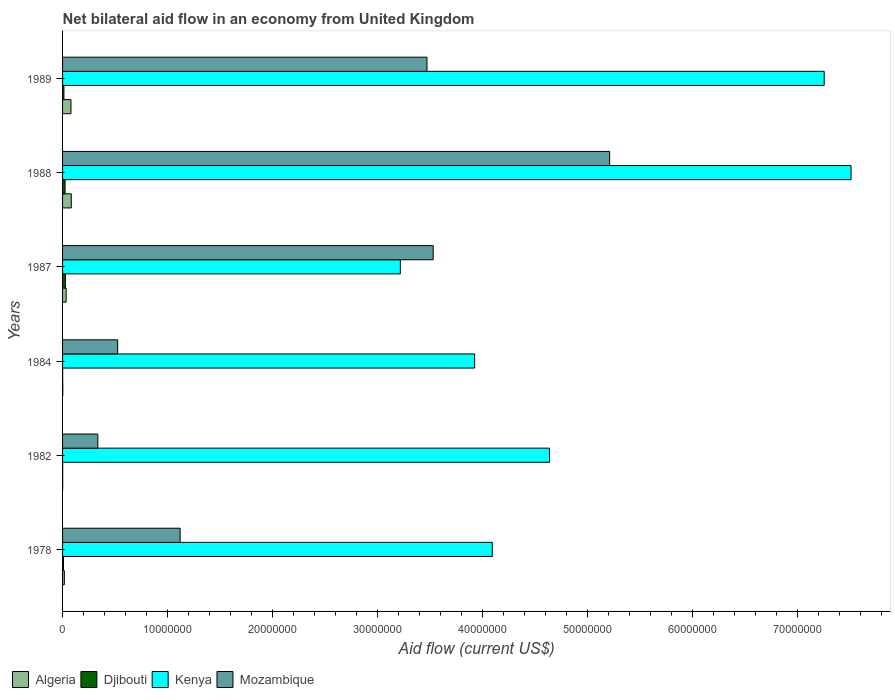How many different coloured bars are there?
Ensure brevity in your answer.  4. How many groups of bars are there?
Give a very brief answer. 6. Are the number of bars per tick equal to the number of legend labels?
Your response must be concise. Yes. How many bars are there on the 2nd tick from the bottom?
Provide a short and direct response. 4. What is the net bilateral aid flow in Kenya in 1988?
Your response must be concise. 7.51e+07. Across all years, what is the maximum net bilateral aid flow in Djibouti?
Ensure brevity in your answer.  2.70e+05. Across all years, what is the minimum net bilateral aid flow in Kenya?
Offer a very short reply. 3.22e+07. In which year was the net bilateral aid flow in Mozambique maximum?
Your answer should be compact. 1988. What is the total net bilateral aid flow in Djibouti in the graph?
Offer a terse response. 7.50e+05. What is the difference between the net bilateral aid flow in Mozambique in 1982 and that in 1988?
Offer a terse response. -4.88e+07. What is the difference between the net bilateral aid flow in Djibouti in 1978 and the net bilateral aid flow in Mozambique in 1984?
Provide a short and direct response. -5.16e+06. What is the average net bilateral aid flow in Djibouti per year?
Offer a very short reply. 1.25e+05. In the year 1984, what is the difference between the net bilateral aid flow in Mozambique and net bilateral aid flow in Kenya?
Provide a succinct answer. -3.40e+07. In how many years, is the net bilateral aid flow in Mozambique greater than 20000000 US$?
Make the answer very short. 3. What is the ratio of the net bilateral aid flow in Mozambique in 1984 to that in 1988?
Provide a short and direct response. 0.1. Is the net bilateral aid flow in Djibouti in 1984 less than that in 1988?
Your answer should be compact. Yes. Is the difference between the net bilateral aid flow in Mozambique in 1984 and 1989 greater than the difference between the net bilateral aid flow in Kenya in 1984 and 1989?
Your answer should be very brief. Yes. What is the difference between the highest and the second highest net bilateral aid flow in Mozambique?
Your response must be concise. 1.68e+07. Is the sum of the net bilateral aid flow in Kenya in 1987 and 1989 greater than the maximum net bilateral aid flow in Algeria across all years?
Your answer should be very brief. Yes. What does the 4th bar from the top in 1978 represents?
Give a very brief answer. Algeria. What does the 4th bar from the bottom in 1982 represents?
Your answer should be compact. Mozambique. Is it the case that in every year, the sum of the net bilateral aid flow in Kenya and net bilateral aid flow in Mozambique is greater than the net bilateral aid flow in Algeria?
Make the answer very short. Yes. How many bars are there?
Ensure brevity in your answer.  24. How many years are there in the graph?
Provide a succinct answer. 6. What is the difference between two consecutive major ticks on the X-axis?
Keep it short and to the point. 1.00e+07. Where does the legend appear in the graph?
Your answer should be very brief. Bottom left. How many legend labels are there?
Your response must be concise. 4. What is the title of the graph?
Your response must be concise. Net bilateral aid flow in an economy from United Kingdom. What is the Aid flow (current US$) in Algeria in 1978?
Your answer should be compact. 1.70e+05. What is the Aid flow (current US$) of Kenya in 1978?
Ensure brevity in your answer.  4.09e+07. What is the Aid flow (current US$) in Mozambique in 1978?
Your answer should be very brief. 1.12e+07. What is the Aid flow (current US$) in Kenya in 1982?
Provide a succinct answer. 4.64e+07. What is the Aid flow (current US$) of Mozambique in 1982?
Your answer should be very brief. 3.36e+06. What is the Aid flow (current US$) of Djibouti in 1984?
Your answer should be very brief. 10000. What is the Aid flow (current US$) of Kenya in 1984?
Offer a very short reply. 3.93e+07. What is the Aid flow (current US$) in Mozambique in 1984?
Your answer should be very brief. 5.25e+06. What is the Aid flow (current US$) in Djibouti in 1987?
Your answer should be very brief. 2.70e+05. What is the Aid flow (current US$) of Kenya in 1987?
Offer a very short reply. 3.22e+07. What is the Aid flow (current US$) in Mozambique in 1987?
Your response must be concise. 3.53e+07. What is the Aid flow (current US$) of Algeria in 1988?
Provide a short and direct response. 8.30e+05. What is the Aid flow (current US$) in Djibouti in 1988?
Your response must be concise. 2.40e+05. What is the Aid flow (current US$) of Kenya in 1988?
Provide a succinct answer. 7.51e+07. What is the Aid flow (current US$) of Mozambique in 1988?
Make the answer very short. 5.21e+07. What is the Aid flow (current US$) of Kenya in 1989?
Give a very brief answer. 7.26e+07. What is the Aid flow (current US$) in Mozambique in 1989?
Offer a very short reply. 3.47e+07. Across all years, what is the maximum Aid flow (current US$) of Algeria?
Provide a short and direct response. 8.30e+05. Across all years, what is the maximum Aid flow (current US$) of Djibouti?
Provide a short and direct response. 2.70e+05. Across all years, what is the maximum Aid flow (current US$) of Kenya?
Ensure brevity in your answer.  7.51e+07. Across all years, what is the maximum Aid flow (current US$) of Mozambique?
Offer a terse response. 5.21e+07. Across all years, what is the minimum Aid flow (current US$) of Djibouti?
Keep it short and to the point. 10000. Across all years, what is the minimum Aid flow (current US$) in Kenya?
Give a very brief answer. 3.22e+07. Across all years, what is the minimum Aid flow (current US$) of Mozambique?
Ensure brevity in your answer.  3.36e+06. What is the total Aid flow (current US$) of Algeria in the graph?
Keep it short and to the point. 2.17e+06. What is the total Aid flow (current US$) of Djibouti in the graph?
Offer a terse response. 7.50e+05. What is the total Aid flow (current US$) of Kenya in the graph?
Your answer should be very brief. 3.06e+08. What is the total Aid flow (current US$) of Mozambique in the graph?
Provide a succinct answer. 1.42e+08. What is the difference between the Aid flow (current US$) in Algeria in 1978 and that in 1982?
Make the answer very short. 1.60e+05. What is the difference between the Aid flow (current US$) of Kenya in 1978 and that in 1982?
Offer a terse response. -5.45e+06. What is the difference between the Aid flow (current US$) of Mozambique in 1978 and that in 1982?
Provide a short and direct response. 7.84e+06. What is the difference between the Aid flow (current US$) in Kenya in 1978 and that in 1984?
Provide a short and direct response. 1.68e+06. What is the difference between the Aid flow (current US$) in Mozambique in 1978 and that in 1984?
Your answer should be very brief. 5.95e+06. What is the difference between the Aid flow (current US$) of Kenya in 1978 and that in 1987?
Your response must be concise. 8.76e+06. What is the difference between the Aid flow (current US$) in Mozambique in 1978 and that in 1987?
Keep it short and to the point. -2.41e+07. What is the difference between the Aid flow (current US$) in Algeria in 1978 and that in 1988?
Ensure brevity in your answer.  -6.60e+05. What is the difference between the Aid flow (current US$) of Djibouti in 1978 and that in 1988?
Ensure brevity in your answer.  -1.50e+05. What is the difference between the Aid flow (current US$) in Kenya in 1978 and that in 1988?
Your answer should be compact. -3.42e+07. What is the difference between the Aid flow (current US$) of Mozambique in 1978 and that in 1988?
Make the answer very short. -4.09e+07. What is the difference between the Aid flow (current US$) in Algeria in 1978 and that in 1989?
Your response must be concise. -6.30e+05. What is the difference between the Aid flow (current US$) in Djibouti in 1978 and that in 1989?
Offer a very short reply. -4.00e+04. What is the difference between the Aid flow (current US$) of Kenya in 1978 and that in 1989?
Keep it short and to the point. -3.16e+07. What is the difference between the Aid flow (current US$) of Mozambique in 1978 and that in 1989?
Offer a very short reply. -2.35e+07. What is the difference between the Aid flow (current US$) of Djibouti in 1982 and that in 1984?
Make the answer very short. 0. What is the difference between the Aid flow (current US$) of Kenya in 1982 and that in 1984?
Your response must be concise. 7.13e+06. What is the difference between the Aid flow (current US$) of Mozambique in 1982 and that in 1984?
Give a very brief answer. -1.89e+06. What is the difference between the Aid flow (current US$) in Algeria in 1982 and that in 1987?
Keep it short and to the point. -3.30e+05. What is the difference between the Aid flow (current US$) of Kenya in 1982 and that in 1987?
Your response must be concise. 1.42e+07. What is the difference between the Aid flow (current US$) of Mozambique in 1982 and that in 1987?
Your answer should be very brief. -3.20e+07. What is the difference between the Aid flow (current US$) in Algeria in 1982 and that in 1988?
Your answer should be very brief. -8.20e+05. What is the difference between the Aid flow (current US$) in Kenya in 1982 and that in 1988?
Offer a terse response. -2.87e+07. What is the difference between the Aid flow (current US$) of Mozambique in 1982 and that in 1988?
Provide a succinct answer. -4.88e+07. What is the difference between the Aid flow (current US$) of Algeria in 1982 and that in 1989?
Your response must be concise. -7.90e+05. What is the difference between the Aid flow (current US$) of Djibouti in 1982 and that in 1989?
Your response must be concise. -1.20e+05. What is the difference between the Aid flow (current US$) in Kenya in 1982 and that in 1989?
Ensure brevity in your answer.  -2.62e+07. What is the difference between the Aid flow (current US$) of Mozambique in 1982 and that in 1989?
Your answer should be compact. -3.14e+07. What is the difference between the Aid flow (current US$) in Algeria in 1984 and that in 1987?
Your answer should be compact. -3.20e+05. What is the difference between the Aid flow (current US$) in Kenya in 1984 and that in 1987?
Provide a succinct answer. 7.08e+06. What is the difference between the Aid flow (current US$) in Mozambique in 1984 and that in 1987?
Your answer should be compact. -3.01e+07. What is the difference between the Aid flow (current US$) in Algeria in 1984 and that in 1988?
Your response must be concise. -8.10e+05. What is the difference between the Aid flow (current US$) in Kenya in 1984 and that in 1988?
Offer a terse response. -3.59e+07. What is the difference between the Aid flow (current US$) of Mozambique in 1984 and that in 1988?
Your answer should be compact. -4.69e+07. What is the difference between the Aid flow (current US$) of Algeria in 1984 and that in 1989?
Offer a very short reply. -7.80e+05. What is the difference between the Aid flow (current US$) in Kenya in 1984 and that in 1989?
Offer a terse response. -3.33e+07. What is the difference between the Aid flow (current US$) in Mozambique in 1984 and that in 1989?
Keep it short and to the point. -2.95e+07. What is the difference between the Aid flow (current US$) in Algeria in 1987 and that in 1988?
Your answer should be compact. -4.90e+05. What is the difference between the Aid flow (current US$) in Djibouti in 1987 and that in 1988?
Provide a short and direct response. 3.00e+04. What is the difference between the Aid flow (current US$) of Kenya in 1987 and that in 1988?
Offer a very short reply. -4.29e+07. What is the difference between the Aid flow (current US$) in Mozambique in 1987 and that in 1988?
Your response must be concise. -1.68e+07. What is the difference between the Aid flow (current US$) of Algeria in 1987 and that in 1989?
Give a very brief answer. -4.60e+05. What is the difference between the Aid flow (current US$) of Djibouti in 1987 and that in 1989?
Ensure brevity in your answer.  1.40e+05. What is the difference between the Aid flow (current US$) in Kenya in 1987 and that in 1989?
Provide a succinct answer. -4.04e+07. What is the difference between the Aid flow (current US$) of Mozambique in 1987 and that in 1989?
Keep it short and to the point. 5.90e+05. What is the difference between the Aid flow (current US$) of Djibouti in 1988 and that in 1989?
Ensure brevity in your answer.  1.10e+05. What is the difference between the Aid flow (current US$) of Kenya in 1988 and that in 1989?
Offer a very short reply. 2.56e+06. What is the difference between the Aid flow (current US$) of Mozambique in 1988 and that in 1989?
Keep it short and to the point. 1.74e+07. What is the difference between the Aid flow (current US$) in Algeria in 1978 and the Aid flow (current US$) in Djibouti in 1982?
Ensure brevity in your answer.  1.60e+05. What is the difference between the Aid flow (current US$) of Algeria in 1978 and the Aid flow (current US$) of Kenya in 1982?
Your answer should be compact. -4.62e+07. What is the difference between the Aid flow (current US$) in Algeria in 1978 and the Aid flow (current US$) in Mozambique in 1982?
Keep it short and to the point. -3.19e+06. What is the difference between the Aid flow (current US$) in Djibouti in 1978 and the Aid flow (current US$) in Kenya in 1982?
Provide a succinct answer. -4.63e+07. What is the difference between the Aid flow (current US$) of Djibouti in 1978 and the Aid flow (current US$) of Mozambique in 1982?
Provide a succinct answer. -3.27e+06. What is the difference between the Aid flow (current US$) in Kenya in 1978 and the Aid flow (current US$) in Mozambique in 1982?
Ensure brevity in your answer.  3.76e+07. What is the difference between the Aid flow (current US$) in Algeria in 1978 and the Aid flow (current US$) in Djibouti in 1984?
Keep it short and to the point. 1.60e+05. What is the difference between the Aid flow (current US$) of Algeria in 1978 and the Aid flow (current US$) of Kenya in 1984?
Your answer should be compact. -3.91e+07. What is the difference between the Aid flow (current US$) in Algeria in 1978 and the Aid flow (current US$) in Mozambique in 1984?
Your response must be concise. -5.08e+06. What is the difference between the Aid flow (current US$) in Djibouti in 1978 and the Aid flow (current US$) in Kenya in 1984?
Make the answer very short. -3.92e+07. What is the difference between the Aid flow (current US$) in Djibouti in 1978 and the Aid flow (current US$) in Mozambique in 1984?
Your response must be concise. -5.16e+06. What is the difference between the Aid flow (current US$) of Kenya in 1978 and the Aid flow (current US$) of Mozambique in 1984?
Your response must be concise. 3.57e+07. What is the difference between the Aid flow (current US$) of Algeria in 1978 and the Aid flow (current US$) of Kenya in 1987?
Provide a short and direct response. -3.20e+07. What is the difference between the Aid flow (current US$) of Algeria in 1978 and the Aid flow (current US$) of Mozambique in 1987?
Your answer should be compact. -3.51e+07. What is the difference between the Aid flow (current US$) in Djibouti in 1978 and the Aid flow (current US$) in Kenya in 1987?
Your answer should be very brief. -3.21e+07. What is the difference between the Aid flow (current US$) in Djibouti in 1978 and the Aid flow (current US$) in Mozambique in 1987?
Your answer should be very brief. -3.52e+07. What is the difference between the Aid flow (current US$) in Kenya in 1978 and the Aid flow (current US$) in Mozambique in 1987?
Ensure brevity in your answer.  5.63e+06. What is the difference between the Aid flow (current US$) of Algeria in 1978 and the Aid flow (current US$) of Djibouti in 1988?
Make the answer very short. -7.00e+04. What is the difference between the Aid flow (current US$) in Algeria in 1978 and the Aid flow (current US$) in Kenya in 1988?
Provide a succinct answer. -7.50e+07. What is the difference between the Aid flow (current US$) in Algeria in 1978 and the Aid flow (current US$) in Mozambique in 1988?
Your response must be concise. -5.20e+07. What is the difference between the Aid flow (current US$) of Djibouti in 1978 and the Aid flow (current US$) of Kenya in 1988?
Make the answer very short. -7.50e+07. What is the difference between the Aid flow (current US$) in Djibouti in 1978 and the Aid flow (current US$) in Mozambique in 1988?
Your answer should be very brief. -5.20e+07. What is the difference between the Aid flow (current US$) of Kenya in 1978 and the Aid flow (current US$) of Mozambique in 1988?
Your response must be concise. -1.12e+07. What is the difference between the Aid flow (current US$) of Algeria in 1978 and the Aid flow (current US$) of Djibouti in 1989?
Your answer should be compact. 4.00e+04. What is the difference between the Aid flow (current US$) in Algeria in 1978 and the Aid flow (current US$) in Kenya in 1989?
Your answer should be compact. -7.24e+07. What is the difference between the Aid flow (current US$) in Algeria in 1978 and the Aid flow (current US$) in Mozambique in 1989?
Give a very brief answer. -3.46e+07. What is the difference between the Aid flow (current US$) in Djibouti in 1978 and the Aid flow (current US$) in Kenya in 1989?
Give a very brief answer. -7.25e+07. What is the difference between the Aid flow (current US$) in Djibouti in 1978 and the Aid flow (current US$) in Mozambique in 1989?
Give a very brief answer. -3.46e+07. What is the difference between the Aid flow (current US$) of Kenya in 1978 and the Aid flow (current US$) of Mozambique in 1989?
Provide a short and direct response. 6.22e+06. What is the difference between the Aid flow (current US$) in Algeria in 1982 and the Aid flow (current US$) in Djibouti in 1984?
Keep it short and to the point. 0. What is the difference between the Aid flow (current US$) of Algeria in 1982 and the Aid flow (current US$) of Kenya in 1984?
Give a very brief answer. -3.92e+07. What is the difference between the Aid flow (current US$) in Algeria in 1982 and the Aid flow (current US$) in Mozambique in 1984?
Ensure brevity in your answer.  -5.24e+06. What is the difference between the Aid flow (current US$) in Djibouti in 1982 and the Aid flow (current US$) in Kenya in 1984?
Your answer should be compact. -3.92e+07. What is the difference between the Aid flow (current US$) in Djibouti in 1982 and the Aid flow (current US$) in Mozambique in 1984?
Give a very brief answer. -5.24e+06. What is the difference between the Aid flow (current US$) of Kenya in 1982 and the Aid flow (current US$) of Mozambique in 1984?
Make the answer very short. 4.11e+07. What is the difference between the Aid flow (current US$) of Algeria in 1982 and the Aid flow (current US$) of Djibouti in 1987?
Your response must be concise. -2.60e+05. What is the difference between the Aid flow (current US$) of Algeria in 1982 and the Aid flow (current US$) of Kenya in 1987?
Ensure brevity in your answer.  -3.22e+07. What is the difference between the Aid flow (current US$) of Algeria in 1982 and the Aid flow (current US$) of Mozambique in 1987?
Keep it short and to the point. -3.53e+07. What is the difference between the Aid flow (current US$) of Djibouti in 1982 and the Aid flow (current US$) of Kenya in 1987?
Your answer should be compact. -3.22e+07. What is the difference between the Aid flow (current US$) of Djibouti in 1982 and the Aid flow (current US$) of Mozambique in 1987?
Provide a succinct answer. -3.53e+07. What is the difference between the Aid flow (current US$) of Kenya in 1982 and the Aid flow (current US$) of Mozambique in 1987?
Offer a terse response. 1.11e+07. What is the difference between the Aid flow (current US$) of Algeria in 1982 and the Aid flow (current US$) of Kenya in 1988?
Your answer should be compact. -7.51e+07. What is the difference between the Aid flow (current US$) of Algeria in 1982 and the Aid flow (current US$) of Mozambique in 1988?
Make the answer very short. -5.21e+07. What is the difference between the Aid flow (current US$) of Djibouti in 1982 and the Aid flow (current US$) of Kenya in 1988?
Your answer should be very brief. -7.51e+07. What is the difference between the Aid flow (current US$) in Djibouti in 1982 and the Aid flow (current US$) in Mozambique in 1988?
Your answer should be very brief. -5.21e+07. What is the difference between the Aid flow (current US$) in Kenya in 1982 and the Aid flow (current US$) in Mozambique in 1988?
Offer a very short reply. -5.73e+06. What is the difference between the Aid flow (current US$) of Algeria in 1982 and the Aid flow (current US$) of Djibouti in 1989?
Offer a very short reply. -1.20e+05. What is the difference between the Aid flow (current US$) in Algeria in 1982 and the Aid flow (current US$) in Kenya in 1989?
Provide a short and direct response. -7.26e+07. What is the difference between the Aid flow (current US$) in Algeria in 1982 and the Aid flow (current US$) in Mozambique in 1989?
Your answer should be very brief. -3.47e+07. What is the difference between the Aid flow (current US$) of Djibouti in 1982 and the Aid flow (current US$) of Kenya in 1989?
Make the answer very short. -7.26e+07. What is the difference between the Aid flow (current US$) of Djibouti in 1982 and the Aid flow (current US$) of Mozambique in 1989?
Offer a very short reply. -3.47e+07. What is the difference between the Aid flow (current US$) in Kenya in 1982 and the Aid flow (current US$) in Mozambique in 1989?
Give a very brief answer. 1.17e+07. What is the difference between the Aid flow (current US$) of Algeria in 1984 and the Aid flow (current US$) of Djibouti in 1987?
Your answer should be very brief. -2.50e+05. What is the difference between the Aid flow (current US$) of Algeria in 1984 and the Aid flow (current US$) of Kenya in 1987?
Provide a short and direct response. -3.22e+07. What is the difference between the Aid flow (current US$) of Algeria in 1984 and the Aid flow (current US$) of Mozambique in 1987?
Ensure brevity in your answer.  -3.53e+07. What is the difference between the Aid flow (current US$) in Djibouti in 1984 and the Aid flow (current US$) in Kenya in 1987?
Provide a succinct answer. -3.22e+07. What is the difference between the Aid flow (current US$) in Djibouti in 1984 and the Aid flow (current US$) in Mozambique in 1987?
Provide a succinct answer. -3.53e+07. What is the difference between the Aid flow (current US$) in Kenya in 1984 and the Aid flow (current US$) in Mozambique in 1987?
Your answer should be very brief. 3.95e+06. What is the difference between the Aid flow (current US$) in Algeria in 1984 and the Aid flow (current US$) in Djibouti in 1988?
Your response must be concise. -2.20e+05. What is the difference between the Aid flow (current US$) of Algeria in 1984 and the Aid flow (current US$) of Kenya in 1988?
Provide a succinct answer. -7.51e+07. What is the difference between the Aid flow (current US$) of Algeria in 1984 and the Aid flow (current US$) of Mozambique in 1988?
Offer a terse response. -5.21e+07. What is the difference between the Aid flow (current US$) in Djibouti in 1984 and the Aid flow (current US$) in Kenya in 1988?
Your answer should be very brief. -7.51e+07. What is the difference between the Aid flow (current US$) of Djibouti in 1984 and the Aid flow (current US$) of Mozambique in 1988?
Keep it short and to the point. -5.21e+07. What is the difference between the Aid flow (current US$) of Kenya in 1984 and the Aid flow (current US$) of Mozambique in 1988?
Your response must be concise. -1.29e+07. What is the difference between the Aid flow (current US$) in Algeria in 1984 and the Aid flow (current US$) in Kenya in 1989?
Provide a short and direct response. -7.25e+07. What is the difference between the Aid flow (current US$) of Algeria in 1984 and the Aid flow (current US$) of Mozambique in 1989?
Keep it short and to the point. -3.47e+07. What is the difference between the Aid flow (current US$) of Djibouti in 1984 and the Aid flow (current US$) of Kenya in 1989?
Offer a terse response. -7.26e+07. What is the difference between the Aid flow (current US$) of Djibouti in 1984 and the Aid flow (current US$) of Mozambique in 1989?
Your answer should be very brief. -3.47e+07. What is the difference between the Aid flow (current US$) of Kenya in 1984 and the Aid flow (current US$) of Mozambique in 1989?
Your response must be concise. 4.54e+06. What is the difference between the Aid flow (current US$) in Algeria in 1987 and the Aid flow (current US$) in Kenya in 1988?
Keep it short and to the point. -7.48e+07. What is the difference between the Aid flow (current US$) in Algeria in 1987 and the Aid flow (current US$) in Mozambique in 1988?
Provide a succinct answer. -5.18e+07. What is the difference between the Aid flow (current US$) of Djibouti in 1987 and the Aid flow (current US$) of Kenya in 1988?
Ensure brevity in your answer.  -7.48e+07. What is the difference between the Aid flow (current US$) in Djibouti in 1987 and the Aid flow (current US$) in Mozambique in 1988?
Your answer should be very brief. -5.18e+07. What is the difference between the Aid flow (current US$) of Kenya in 1987 and the Aid flow (current US$) of Mozambique in 1988?
Keep it short and to the point. -1.99e+07. What is the difference between the Aid flow (current US$) in Algeria in 1987 and the Aid flow (current US$) in Djibouti in 1989?
Provide a short and direct response. 2.10e+05. What is the difference between the Aid flow (current US$) of Algeria in 1987 and the Aid flow (current US$) of Kenya in 1989?
Your answer should be compact. -7.22e+07. What is the difference between the Aid flow (current US$) in Algeria in 1987 and the Aid flow (current US$) in Mozambique in 1989?
Provide a short and direct response. -3.44e+07. What is the difference between the Aid flow (current US$) of Djibouti in 1987 and the Aid flow (current US$) of Kenya in 1989?
Offer a terse response. -7.23e+07. What is the difference between the Aid flow (current US$) in Djibouti in 1987 and the Aid flow (current US$) in Mozambique in 1989?
Keep it short and to the point. -3.44e+07. What is the difference between the Aid flow (current US$) in Kenya in 1987 and the Aid flow (current US$) in Mozambique in 1989?
Provide a short and direct response. -2.54e+06. What is the difference between the Aid flow (current US$) in Algeria in 1988 and the Aid flow (current US$) in Kenya in 1989?
Keep it short and to the point. -7.17e+07. What is the difference between the Aid flow (current US$) in Algeria in 1988 and the Aid flow (current US$) in Mozambique in 1989?
Keep it short and to the point. -3.39e+07. What is the difference between the Aid flow (current US$) in Djibouti in 1988 and the Aid flow (current US$) in Kenya in 1989?
Offer a terse response. -7.23e+07. What is the difference between the Aid flow (current US$) in Djibouti in 1988 and the Aid flow (current US$) in Mozambique in 1989?
Offer a very short reply. -3.45e+07. What is the difference between the Aid flow (current US$) of Kenya in 1988 and the Aid flow (current US$) of Mozambique in 1989?
Give a very brief answer. 4.04e+07. What is the average Aid flow (current US$) of Algeria per year?
Your answer should be compact. 3.62e+05. What is the average Aid flow (current US$) in Djibouti per year?
Provide a succinct answer. 1.25e+05. What is the average Aid flow (current US$) in Kenya per year?
Ensure brevity in your answer.  5.11e+07. What is the average Aid flow (current US$) of Mozambique per year?
Your answer should be very brief. 2.37e+07. In the year 1978, what is the difference between the Aid flow (current US$) in Algeria and Aid flow (current US$) in Kenya?
Your response must be concise. -4.08e+07. In the year 1978, what is the difference between the Aid flow (current US$) of Algeria and Aid flow (current US$) of Mozambique?
Your answer should be very brief. -1.10e+07. In the year 1978, what is the difference between the Aid flow (current US$) of Djibouti and Aid flow (current US$) of Kenya?
Your response must be concise. -4.08e+07. In the year 1978, what is the difference between the Aid flow (current US$) in Djibouti and Aid flow (current US$) in Mozambique?
Offer a terse response. -1.11e+07. In the year 1978, what is the difference between the Aid flow (current US$) in Kenya and Aid flow (current US$) in Mozambique?
Offer a very short reply. 2.97e+07. In the year 1982, what is the difference between the Aid flow (current US$) in Algeria and Aid flow (current US$) in Djibouti?
Your answer should be very brief. 0. In the year 1982, what is the difference between the Aid flow (current US$) in Algeria and Aid flow (current US$) in Kenya?
Offer a terse response. -4.64e+07. In the year 1982, what is the difference between the Aid flow (current US$) of Algeria and Aid flow (current US$) of Mozambique?
Keep it short and to the point. -3.35e+06. In the year 1982, what is the difference between the Aid flow (current US$) in Djibouti and Aid flow (current US$) in Kenya?
Make the answer very short. -4.64e+07. In the year 1982, what is the difference between the Aid flow (current US$) in Djibouti and Aid flow (current US$) in Mozambique?
Provide a short and direct response. -3.35e+06. In the year 1982, what is the difference between the Aid flow (current US$) in Kenya and Aid flow (current US$) in Mozambique?
Offer a terse response. 4.30e+07. In the year 1984, what is the difference between the Aid flow (current US$) in Algeria and Aid flow (current US$) in Djibouti?
Keep it short and to the point. 10000. In the year 1984, what is the difference between the Aid flow (current US$) of Algeria and Aid flow (current US$) of Kenya?
Keep it short and to the point. -3.92e+07. In the year 1984, what is the difference between the Aid flow (current US$) of Algeria and Aid flow (current US$) of Mozambique?
Provide a short and direct response. -5.23e+06. In the year 1984, what is the difference between the Aid flow (current US$) of Djibouti and Aid flow (current US$) of Kenya?
Your answer should be very brief. -3.92e+07. In the year 1984, what is the difference between the Aid flow (current US$) of Djibouti and Aid flow (current US$) of Mozambique?
Your response must be concise. -5.24e+06. In the year 1984, what is the difference between the Aid flow (current US$) in Kenya and Aid flow (current US$) in Mozambique?
Offer a terse response. 3.40e+07. In the year 1987, what is the difference between the Aid flow (current US$) in Algeria and Aid flow (current US$) in Kenya?
Provide a succinct answer. -3.18e+07. In the year 1987, what is the difference between the Aid flow (current US$) in Algeria and Aid flow (current US$) in Mozambique?
Offer a terse response. -3.50e+07. In the year 1987, what is the difference between the Aid flow (current US$) of Djibouti and Aid flow (current US$) of Kenya?
Ensure brevity in your answer.  -3.19e+07. In the year 1987, what is the difference between the Aid flow (current US$) in Djibouti and Aid flow (current US$) in Mozambique?
Keep it short and to the point. -3.50e+07. In the year 1987, what is the difference between the Aid flow (current US$) in Kenya and Aid flow (current US$) in Mozambique?
Keep it short and to the point. -3.13e+06. In the year 1988, what is the difference between the Aid flow (current US$) of Algeria and Aid flow (current US$) of Djibouti?
Your answer should be very brief. 5.90e+05. In the year 1988, what is the difference between the Aid flow (current US$) in Algeria and Aid flow (current US$) in Kenya?
Ensure brevity in your answer.  -7.43e+07. In the year 1988, what is the difference between the Aid flow (current US$) of Algeria and Aid flow (current US$) of Mozambique?
Your answer should be very brief. -5.13e+07. In the year 1988, what is the difference between the Aid flow (current US$) of Djibouti and Aid flow (current US$) of Kenya?
Keep it short and to the point. -7.49e+07. In the year 1988, what is the difference between the Aid flow (current US$) of Djibouti and Aid flow (current US$) of Mozambique?
Ensure brevity in your answer.  -5.19e+07. In the year 1988, what is the difference between the Aid flow (current US$) of Kenya and Aid flow (current US$) of Mozambique?
Give a very brief answer. 2.30e+07. In the year 1989, what is the difference between the Aid flow (current US$) in Algeria and Aid flow (current US$) in Djibouti?
Ensure brevity in your answer.  6.70e+05. In the year 1989, what is the difference between the Aid flow (current US$) in Algeria and Aid flow (current US$) in Kenya?
Keep it short and to the point. -7.18e+07. In the year 1989, what is the difference between the Aid flow (current US$) in Algeria and Aid flow (current US$) in Mozambique?
Make the answer very short. -3.39e+07. In the year 1989, what is the difference between the Aid flow (current US$) in Djibouti and Aid flow (current US$) in Kenya?
Offer a terse response. -7.24e+07. In the year 1989, what is the difference between the Aid flow (current US$) in Djibouti and Aid flow (current US$) in Mozambique?
Your answer should be very brief. -3.46e+07. In the year 1989, what is the difference between the Aid flow (current US$) in Kenya and Aid flow (current US$) in Mozambique?
Provide a short and direct response. 3.78e+07. What is the ratio of the Aid flow (current US$) in Algeria in 1978 to that in 1982?
Your answer should be very brief. 17. What is the ratio of the Aid flow (current US$) in Kenya in 1978 to that in 1982?
Keep it short and to the point. 0.88. What is the ratio of the Aid flow (current US$) of Djibouti in 1978 to that in 1984?
Offer a very short reply. 9. What is the ratio of the Aid flow (current US$) in Kenya in 1978 to that in 1984?
Ensure brevity in your answer.  1.04. What is the ratio of the Aid flow (current US$) of Mozambique in 1978 to that in 1984?
Offer a terse response. 2.13. What is the ratio of the Aid flow (current US$) of Algeria in 1978 to that in 1987?
Offer a terse response. 0.5. What is the ratio of the Aid flow (current US$) of Kenya in 1978 to that in 1987?
Make the answer very short. 1.27. What is the ratio of the Aid flow (current US$) in Mozambique in 1978 to that in 1987?
Make the answer very short. 0.32. What is the ratio of the Aid flow (current US$) in Algeria in 1978 to that in 1988?
Provide a short and direct response. 0.2. What is the ratio of the Aid flow (current US$) of Djibouti in 1978 to that in 1988?
Offer a terse response. 0.38. What is the ratio of the Aid flow (current US$) of Kenya in 1978 to that in 1988?
Offer a very short reply. 0.55. What is the ratio of the Aid flow (current US$) of Mozambique in 1978 to that in 1988?
Provide a short and direct response. 0.21. What is the ratio of the Aid flow (current US$) of Algeria in 1978 to that in 1989?
Give a very brief answer. 0.21. What is the ratio of the Aid flow (current US$) of Djibouti in 1978 to that in 1989?
Give a very brief answer. 0.69. What is the ratio of the Aid flow (current US$) of Kenya in 1978 to that in 1989?
Your response must be concise. 0.56. What is the ratio of the Aid flow (current US$) in Mozambique in 1978 to that in 1989?
Your answer should be compact. 0.32. What is the ratio of the Aid flow (current US$) in Kenya in 1982 to that in 1984?
Provide a succinct answer. 1.18. What is the ratio of the Aid flow (current US$) in Mozambique in 1982 to that in 1984?
Provide a succinct answer. 0.64. What is the ratio of the Aid flow (current US$) in Algeria in 1982 to that in 1987?
Provide a succinct answer. 0.03. What is the ratio of the Aid flow (current US$) in Djibouti in 1982 to that in 1987?
Ensure brevity in your answer.  0.04. What is the ratio of the Aid flow (current US$) in Kenya in 1982 to that in 1987?
Offer a terse response. 1.44. What is the ratio of the Aid flow (current US$) in Mozambique in 1982 to that in 1987?
Your answer should be compact. 0.1. What is the ratio of the Aid flow (current US$) in Algeria in 1982 to that in 1988?
Your answer should be compact. 0.01. What is the ratio of the Aid flow (current US$) of Djibouti in 1982 to that in 1988?
Offer a very short reply. 0.04. What is the ratio of the Aid flow (current US$) of Kenya in 1982 to that in 1988?
Your answer should be compact. 0.62. What is the ratio of the Aid flow (current US$) in Mozambique in 1982 to that in 1988?
Your response must be concise. 0.06. What is the ratio of the Aid flow (current US$) of Algeria in 1982 to that in 1989?
Offer a very short reply. 0.01. What is the ratio of the Aid flow (current US$) of Djibouti in 1982 to that in 1989?
Ensure brevity in your answer.  0.08. What is the ratio of the Aid flow (current US$) in Kenya in 1982 to that in 1989?
Give a very brief answer. 0.64. What is the ratio of the Aid flow (current US$) of Mozambique in 1982 to that in 1989?
Your answer should be compact. 0.1. What is the ratio of the Aid flow (current US$) of Algeria in 1984 to that in 1987?
Offer a terse response. 0.06. What is the ratio of the Aid flow (current US$) of Djibouti in 1984 to that in 1987?
Give a very brief answer. 0.04. What is the ratio of the Aid flow (current US$) of Kenya in 1984 to that in 1987?
Provide a succinct answer. 1.22. What is the ratio of the Aid flow (current US$) in Mozambique in 1984 to that in 1987?
Offer a very short reply. 0.15. What is the ratio of the Aid flow (current US$) of Algeria in 1984 to that in 1988?
Ensure brevity in your answer.  0.02. What is the ratio of the Aid flow (current US$) in Djibouti in 1984 to that in 1988?
Your answer should be compact. 0.04. What is the ratio of the Aid flow (current US$) in Kenya in 1984 to that in 1988?
Offer a terse response. 0.52. What is the ratio of the Aid flow (current US$) of Mozambique in 1984 to that in 1988?
Keep it short and to the point. 0.1. What is the ratio of the Aid flow (current US$) in Algeria in 1984 to that in 1989?
Ensure brevity in your answer.  0.03. What is the ratio of the Aid flow (current US$) of Djibouti in 1984 to that in 1989?
Offer a very short reply. 0.08. What is the ratio of the Aid flow (current US$) of Kenya in 1984 to that in 1989?
Keep it short and to the point. 0.54. What is the ratio of the Aid flow (current US$) in Mozambique in 1984 to that in 1989?
Your answer should be compact. 0.15. What is the ratio of the Aid flow (current US$) in Algeria in 1987 to that in 1988?
Ensure brevity in your answer.  0.41. What is the ratio of the Aid flow (current US$) in Djibouti in 1987 to that in 1988?
Keep it short and to the point. 1.12. What is the ratio of the Aid flow (current US$) of Kenya in 1987 to that in 1988?
Your response must be concise. 0.43. What is the ratio of the Aid flow (current US$) of Mozambique in 1987 to that in 1988?
Your answer should be very brief. 0.68. What is the ratio of the Aid flow (current US$) of Algeria in 1987 to that in 1989?
Offer a very short reply. 0.42. What is the ratio of the Aid flow (current US$) of Djibouti in 1987 to that in 1989?
Provide a succinct answer. 2.08. What is the ratio of the Aid flow (current US$) of Kenya in 1987 to that in 1989?
Provide a short and direct response. 0.44. What is the ratio of the Aid flow (current US$) in Algeria in 1988 to that in 1989?
Keep it short and to the point. 1.04. What is the ratio of the Aid flow (current US$) of Djibouti in 1988 to that in 1989?
Provide a succinct answer. 1.85. What is the ratio of the Aid flow (current US$) in Kenya in 1988 to that in 1989?
Your response must be concise. 1.04. What is the ratio of the Aid flow (current US$) in Mozambique in 1988 to that in 1989?
Your answer should be compact. 1.5. What is the difference between the highest and the second highest Aid flow (current US$) of Kenya?
Give a very brief answer. 2.56e+06. What is the difference between the highest and the second highest Aid flow (current US$) of Mozambique?
Ensure brevity in your answer.  1.68e+07. What is the difference between the highest and the lowest Aid flow (current US$) in Algeria?
Offer a terse response. 8.20e+05. What is the difference between the highest and the lowest Aid flow (current US$) in Kenya?
Keep it short and to the point. 4.29e+07. What is the difference between the highest and the lowest Aid flow (current US$) in Mozambique?
Offer a very short reply. 4.88e+07. 